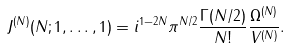Convert formula to latex. <formula><loc_0><loc_0><loc_500><loc_500>J ^ { ( N ) } ( N ; 1 , \dots , 1 ) = i ^ { 1 - 2 N } \pi ^ { N / 2 } \frac { \Gamma ( N / 2 ) } { N ! } \frac { \Omega ^ { ( N ) } } { V ^ { ( N ) } } .</formula> 